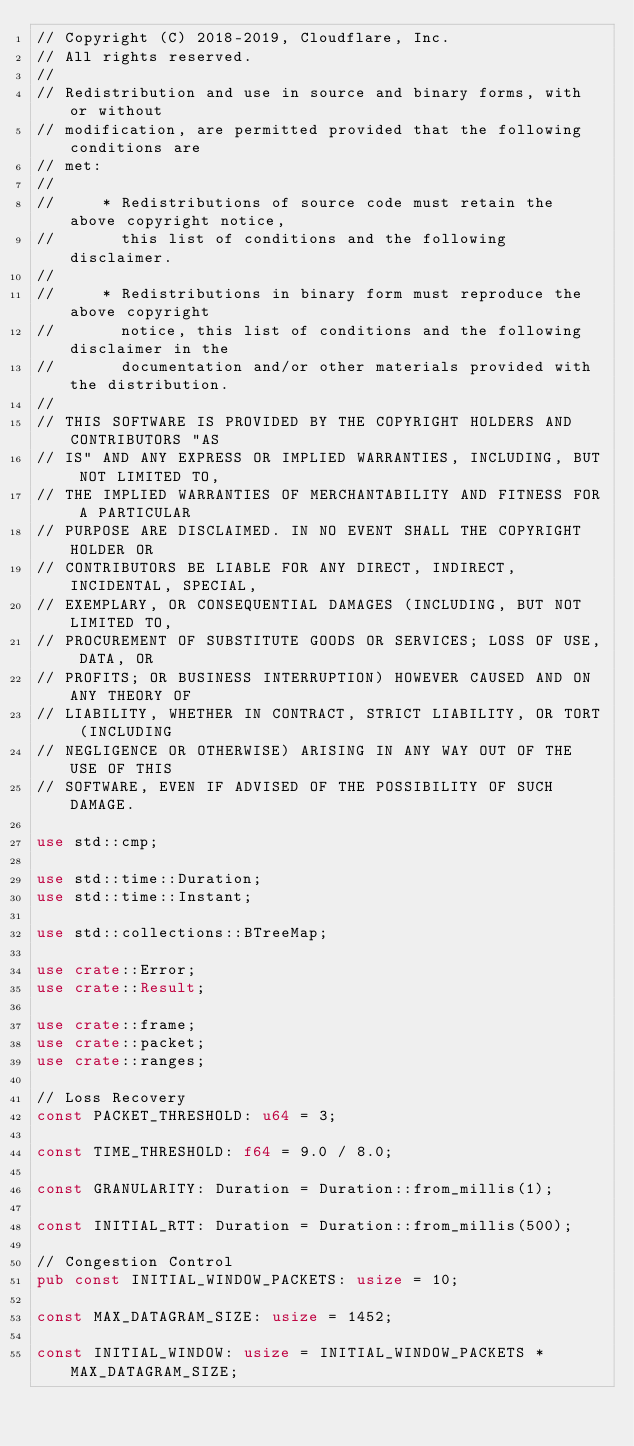<code> <loc_0><loc_0><loc_500><loc_500><_Rust_>// Copyright (C) 2018-2019, Cloudflare, Inc.
// All rights reserved.
//
// Redistribution and use in source and binary forms, with or without
// modification, are permitted provided that the following conditions are
// met:
//
//     * Redistributions of source code must retain the above copyright notice,
//       this list of conditions and the following disclaimer.
//
//     * Redistributions in binary form must reproduce the above copyright
//       notice, this list of conditions and the following disclaimer in the
//       documentation and/or other materials provided with the distribution.
//
// THIS SOFTWARE IS PROVIDED BY THE COPYRIGHT HOLDERS AND CONTRIBUTORS "AS
// IS" AND ANY EXPRESS OR IMPLIED WARRANTIES, INCLUDING, BUT NOT LIMITED TO,
// THE IMPLIED WARRANTIES OF MERCHANTABILITY AND FITNESS FOR A PARTICULAR
// PURPOSE ARE DISCLAIMED. IN NO EVENT SHALL THE COPYRIGHT HOLDER OR
// CONTRIBUTORS BE LIABLE FOR ANY DIRECT, INDIRECT, INCIDENTAL, SPECIAL,
// EXEMPLARY, OR CONSEQUENTIAL DAMAGES (INCLUDING, BUT NOT LIMITED TO,
// PROCUREMENT OF SUBSTITUTE GOODS OR SERVICES; LOSS OF USE, DATA, OR
// PROFITS; OR BUSINESS INTERRUPTION) HOWEVER CAUSED AND ON ANY THEORY OF
// LIABILITY, WHETHER IN CONTRACT, STRICT LIABILITY, OR TORT (INCLUDING
// NEGLIGENCE OR OTHERWISE) ARISING IN ANY WAY OUT OF THE USE OF THIS
// SOFTWARE, EVEN IF ADVISED OF THE POSSIBILITY OF SUCH DAMAGE.

use std::cmp;

use std::time::Duration;
use std::time::Instant;

use std::collections::BTreeMap;

use crate::Error;
use crate::Result;

use crate::frame;
use crate::packet;
use crate::ranges;

// Loss Recovery
const PACKET_THRESHOLD: u64 = 3;

const TIME_THRESHOLD: f64 = 9.0 / 8.0;

const GRANULARITY: Duration = Duration::from_millis(1);

const INITIAL_RTT: Duration = Duration::from_millis(500);

// Congestion Control
pub const INITIAL_WINDOW_PACKETS: usize = 10;

const MAX_DATAGRAM_SIZE: usize = 1452;

const INITIAL_WINDOW: usize = INITIAL_WINDOW_PACKETS * MAX_DATAGRAM_SIZE;</code> 